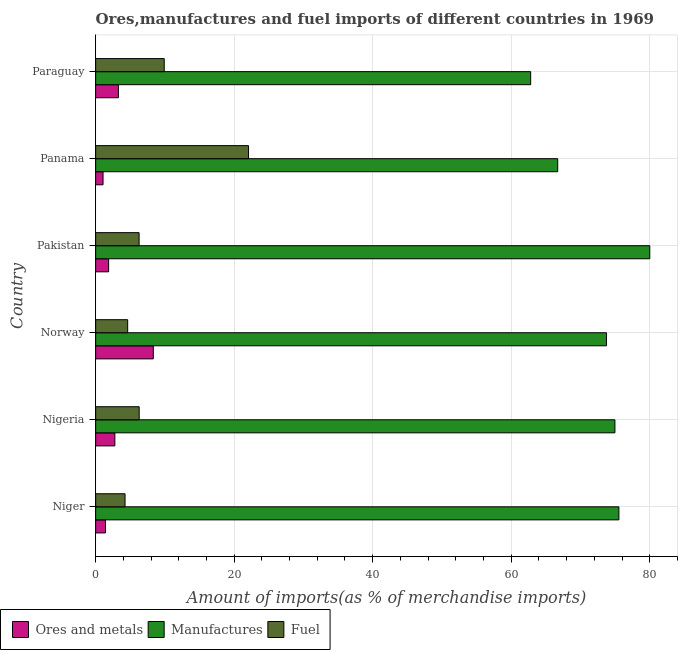How many different coloured bars are there?
Ensure brevity in your answer.  3. How many groups of bars are there?
Provide a short and direct response. 6. Are the number of bars per tick equal to the number of legend labels?
Your answer should be very brief. Yes. What is the label of the 6th group of bars from the top?
Offer a terse response. Niger. What is the percentage of fuel imports in Panama?
Your answer should be very brief. 22.07. Across all countries, what is the maximum percentage of ores and metals imports?
Give a very brief answer. 8.32. Across all countries, what is the minimum percentage of manufactures imports?
Give a very brief answer. 62.81. In which country was the percentage of fuel imports maximum?
Your answer should be compact. Panama. In which country was the percentage of fuel imports minimum?
Make the answer very short. Niger. What is the total percentage of fuel imports in the graph?
Offer a terse response. 53.4. What is the difference between the percentage of fuel imports in Pakistan and that in Paraguay?
Offer a very short reply. -3.63. What is the difference between the percentage of ores and metals imports in Panama and the percentage of manufactures imports in Niger?
Your answer should be very brief. -74.48. What is the average percentage of manufactures imports per country?
Your answer should be very brief. 72.3. What is the difference between the percentage of ores and metals imports and percentage of manufactures imports in Panama?
Give a very brief answer. -65.65. What is the ratio of the percentage of fuel imports in Norway to that in Panama?
Provide a succinct answer. 0.21. Is the difference between the percentage of ores and metals imports in Norway and Paraguay greater than the difference between the percentage of fuel imports in Norway and Paraguay?
Provide a short and direct response. Yes. What is the difference between the highest and the second highest percentage of manufactures imports?
Provide a succinct answer. 4.46. In how many countries, is the percentage of ores and metals imports greater than the average percentage of ores and metals imports taken over all countries?
Offer a very short reply. 2. Is the sum of the percentage of ores and metals imports in Nigeria and Pakistan greater than the maximum percentage of fuel imports across all countries?
Your answer should be compact. No. What does the 2nd bar from the top in Pakistan represents?
Give a very brief answer. Manufactures. What does the 3rd bar from the bottom in Pakistan represents?
Offer a terse response. Fuel. Is it the case that in every country, the sum of the percentage of ores and metals imports and percentage of manufactures imports is greater than the percentage of fuel imports?
Your answer should be very brief. Yes. How many bars are there?
Make the answer very short. 18. How many countries are there in the graph?
Ensure brevity in your answer.  6. What is the difference between two consecutive major ticks on the X-axis?
Offer a very short reply. 20. Are the values on the major ticks of X-axis written in scientific E-notation?
Keep it short and to the point. No. Does the graph contain grids?
Give a very brief answer. Yes. What is the title of the graph?
Your answer should be very brief. Ores,manufactures and fuel imports of different countries in 1969. What is the label or title of the X-axis?
Offer a terse response. Amount of imports(as % of merchandise imports). What is the label or title of the Y-axis?
Offer a terse response. Country. What is the Amount of imports(as % of merchandise imports) in Ores and metals in Niger?
Ensure brevity in your answer.  1.42. What is the Amount of imports(as % of merchandise imports) in Manufactures in Niger?
Offer a very short reply. 75.55. What is the Amount of imports(as % of merchandise imports) in Fuel in Niger?
Make the answer very short. 4.24. What is the Amount of imports(as % of merchandise imports) in Ores and metals in Nigeria?
Your answer should be very brief. 2.77. What is the Amount of imports(as % of merchandise imports) of Manufactures in Nigeria?
Keep it short and to the point. 74.97. What is the Amount of imports(as % of merchandise imports) in Fuel in Nigeria?
Ensure brevity in your answer.  6.28. What is the Amount of imports(as % of merchandise imports) in Ores and metals in Norway?
Give a very brief answer. 8.32. What is the Amount of imports(as % of merchandise imports) of Manufactures in Norway?
Ensure brevity in your answer.  73.75. What is the Amount of imports(as % of merchandise imports) in Fuel in Norway?
Offer a very short reply. 4.62. What is the Amount of imports(as % of merchandise imports) in Ores and metals in Pakistan?
Offer a terse response. 1.87. What is the Amount of imports(as % of merchandise imports) in Manufactures in Pakistan?
Ensure brevity in your answer.  80.01. What is the Amount of imports(as % of merchandise imports) of Fuel in Pakistan?
Give a very brief answer. 6.27. What is the Amount of imports(as % of merchandise imports) of Ores and metals in Panama?
Keep it short and to the point. 1.07. What is the Amount of imports(as % of merchandise imports) of Manufactures in Panama?
Keep it short and to the point. 66.71. What is the Amount of imports(as % of merchandise imports) in Fuel in Panama?
Keep it short and to the point. 22.07. What is the Amount of imports(as % of merchandise imports) of Ores and metals in Paraguay?
Provide a short and direct response. 3.28. What is the Amount of imports(as % of merchandise imports) of Manufactures in Paraguay?
Make the answer very short. 62.81. What is the Amount of imports(as % of merchandise imports) in Fuel in Paraguay?
Make the answer very short. 9.9. Across all countries, what is the maximum Amount of imports(as % of merchandise imports) in Ores and metals?
Give a very brief answer. 8.32. Across all countries, what is the maximum Amount of imports(as % of merchandise imports) in Manufactures?
Give a very brief answer. 80.01. Across all countries, what is the maximum Amount of imports(as % of merchandise imports) in Fuel?
Your answer should be compact. 22.07. Across all countries, what is the minimum Amount of imports(as % of merchandise imports) in Ores and metals?
Ensure brevity in your answer.  1.07. Across all countries, what is the minimum Amount of imports(as % of merchandise imports) in Manufactures?
Your answer should be very brief. 62.81. Across all countries, what is the minimum Amount of imports(as % of merchandise imports) of Fuel?
Offer a very short reply. 4.24. What is the total Amount of imports(as % of merchandise imports) of Ores and metals in the graph?
Keep it short and to the point. 18.74. What is the total Amount of imports(as % of merchandise imports) in Manufactures in the graph?
Provide a short and direct response. 433.81. What is the total Amount of imports(as % of merchandise imports) of Fuel in the graph?
Offer a very short reply. 53.4. What is the difference between the Amount of imports(as % of merchandise imports) in Ores and metals in Niger and that in Nigeria?
Give a very brief answer. -1.35. What is the difference between the Amount of imports(as % of merchandise imports) of Manufactures in Niger and that in Nigeria?
Offer a very short reply. 0.57. What is the difference between the Amount of imports(as % of merchandise imports) of Fuel in Niger and that in Nigeria?
Give a very brief answer. -2.04. What is the difference between the Amount of imports(as % of merchandise imports) of Ores and metals in Niger and that in Norway?
Ensure brevity in your answer.  -6.91. What is the difference between the Amount of imports(as % of merchandise imports) of Manufactures in Niger and that in Norway?
Keep it short and to the point. 1.79. What is the difference between the Amount of imports(as % of merchandise imports) of Fuel in Niger and that in Norway?
Ensure brevity in your answer.  -0.38. What is the difference between the Amount of imports(as % of merchandise imports) in Ores and metals in Niger and that in Pakistan?
Your answer should be very brief. -0.45. What is the difference between the Amount of imports(as % of merchandise imports) in Manufactures in Niger and that in Pakistan?
Your answer should be very brief. -4.46. What is the difference between the Amount of imports(as % of merchandise imports) of Fuel in Niger and that in Pakistan?
Offer a terse response. -2.03. What is the difference between the Amount of imports(as % of merchandise imports) of Ores and metals in Niger and that in Panama?
Keep it short and to the point. 0.35. What is the difference between the Amount of imports(as % of merchandise imports) of Manufactures in Niger and that in Panama?
Your response must be concise. 8.84. What is the difference between the Amount of imports(as % of merchandise imports) in Fuel in Niger and that in Panama?
Give a very brief answer. -17.83. What is the difference between the Amount of imports(as % of merchandise imports) of Ores and metals in Niger and that in Paraguay?
Your answer should be compact. -1.87. What is the difference between the Amount of imports(as % of merchandise imports) of Manufactures in Niger and that in Paraguay?
Provide a short and direct response. 12.74. What is the difference between the Amount of imports(as % of merchandise imports) in Fuel in Niger and that in Paraguay?
Make the answer very short. -5.66. What is the difference between the Amount of imports(as % of merchandise imports) of Ores and metals in Nigeria and that in Norway?
Offer a very short reply. -5.55. What is the difference between the Amount of imports(as % of merchandise imports) of Manufactures in Nigeria and that in Norway?
Keep it short and to the point. 1.22. What is the difference between the Amount of imports(as % of merchandise imports) in Fuel in Nigeria and that in Norway?
Provide a succinct answer. 1.66. What is the difference between the Amount of imports(as % of merchandise imports) in Ores and metals in Nigeria and that in Pakistan?
Give a very brief answer. 0.9. What is the difference between the Amount of imports(as % of merchandise imports) of Manufactures in Nigeria and that in Pakistan?
Offer a very short reply. -5.03. What is the difference between the Amount of imports(as % of merchandise imports) in Fuel in Nigeria and that in Pakistan?
Offer a terse response. 0.01. What is the difference between the Amount of imports(as % of merchandise imports) of Ores and metals in Nigeria and that in Panama?
Provide a succinct answer. 1.7. What is the difference between the Amount of imports(as % of merchandise imports) in Manufactures in Nigeria and that in Panama?
Provide a short and direct response. 8.26. What is the difference between the Amount of imports(as % of merchandise imports) in Fuel in Nigeria and that in Panama?
Keep it short and to the point. -15.79. What is the difference between the Amount of imports(as % of merchandise imports) of Ores and metals in Nigeria and that in Paraguay?
Keep it short and to the point. -0.51. What is the difference between the Amount of imports(as % of merchandise imports) in Manufactures in Nigeria and that in Paraguay?
Your answer should be compact. 12.16. What is the difference between the Amount of imports(as % of merchandise imports) of Fuel in Nigeria and that in Paraguay?
Keep it short and to the point. -3.61. What is the difference between the Amount of imports(as % of merchandise imports) in Ores and metals in Norway and that in Pakistan?
Offer a very short reply. 6.45. What is the difference between the Amount of imports(as % of merchandise imports) in Manufactures in Norway and that in Pakistan?
Ensure brevity in your answer.  -6.26. What is the difference between the Amount of imports(as % of merchandise imports) of Fuel in Norway and that in Pakistan?
Make the answer very short. -1.65. What is the difference between the Amount of imports(as % of merchandise imports) in Ores and metals in Norway and that in Panama?
Your response must be concise. 7.26. What is the difference between the Amount of imports(as % of merchandise imports) of Manufactures in Norway and that in Panama?
Your answer should be very brief. 7.04. What is the difference between the Amount of imports(as % of merchandise imports) in Fuel in Norway and that in Panama?
Offer a very short reply. -17.45. What is the difference between the Amount of imports(as % of merchandise imports) of Ores and metals in Norway and that in Paraguay?
Your response must be concise. 5.04. What is the difference between the Amount of imports(as % of merchandise imports) in Manufactures in Norway and that in Paraguay?
Make the answer very short. 10.94. What is the difference between the Amount of imports(as % of merchandise imports) of Fuel in Norway and that in Paraguay?
Your response must be concise. -5.28. What is the difference between the Amount of imports(as % of merchandise imports) in Ores and metals in Pakistan and that in Panama?
Your answer should be compact. 0.81. What is the difference between the Amount of imports(as % of merchandise imports) of Manufactures in Pakistan and that in Panama?
Provide a succinct answer. 13.3. What is the difference between the Amount of imports(as % of merchandise imports) in Fuel in Pakistan and that in Panama?
Provide a short and direct response. -15.8. What is the difference between the Amount of imports(as % of merchandise imports) in Ores and metals in Pakistan and that in Paraguay?
Provide a short and direct response. -1.41. What is the difference between the Amount of imports(as % of merchandise imports) in Manufactures in Pakistan and that in Paraguay?
Offer a very short reply. 17.2. What is the difference between the Amount of imports(as % of merchandise imports) in Fuel in Pakistan and that in Paraguay?
Your response must be concise. -3.63. What is the difference between the Amount of imports(as % of merchandise imports) of Ores and metals in Panama and that in Paraguay?
Make the answer very short. -2.22. What is the difference between the Amount of imports(as % of merchandise imports) in Manufactures in Panama and that in Paraguay?
Your answer should be very brief. 3.9. What is the difference between the Amount of imports(as % of merchandise imports) of Fuel in Panama and that in Paraguay?
Offer a terse response. 12.17. What is the difference between the Amount of imports(as % of merchandise imports) in Ores and metals in Niger and the Amount of imports(as % of merchandise imports) in Manufactures in Nigeria?
Give a very brief answer. -73.56. What is the difference between the Amount of imports(as % of merchandise imports) of Ores and metals in Niger and the Amount of imports(as % of merchandise imports) of Fuel in Nigeria?
Give a very brief answer. -4.87. What is the difference between the Amount of imports(as % of merchandise imports) of Manufactures in Niger and the Amount of imports(as % of merchandise imports) of Fuel in Nigeria?
Provide a short and direct response. 69.26. What is the difference between the Amount of imports(as % of merchandise imports) in Ores and metals in Niger and the Amount of imports(as % of merchandise imports) in Manufactures in Norway?
Provide a succinct answer. -72.33. What is the difference between the Amount of imports(as % of merchandise imports) in Ores and metals in Niger and the Amount of imports(as % of merchandise imports) in Fuel in Norway?
Your response must be concise. -3.2. What is the difference between the Amount of imports(as % of merchandise imports) in Manufactures in Niger and the Amount of imports(as % of merchandise imports) in Fuel in Norway?
Provide a succinct answer. 70.93. What is the difference between the Amount of imports(as % of merchandise imports) in Ores and metals in Niger and the Amount of imports(as % of merchandise imports) in Manufactures in Pakistan?
Keep it short and to the point. -78.59. What is the difference between the Amount of imports(as % of merchandise imports) of Ores and metals in Niger and the Amount of imports(as % of merchandise imports) of Fuel in Pakistan?
Offer a terse response. -4.85. What is the difference between the Amount of imports(as % of merchandise imports) in Manufactures in Niger and the Amount of imports(as % of merchandise imports) in Fuel in Pakistan?
Make the answer very short. 69.28. What is the difference between the Amount of imports(as % of merchandise imports) of Ores and metals in Niger and the Amount of imports(as % of merchandise imports) of Manufactures in Panama?
Ensure brevity in your answer.  -65.29. What is the difference between the Amount of imports(as % of merchandise imports) of Ores and metals in Niger and the Amount of imports(as % of merchandise imports) of Fuel in Panama?
Your answer should be very brief. -20.65. What is the difference between the Amount of imports(as % of merchandise imports) in Manufactures in Niger and the Amount of imports(as % of merchandise imports) in Fuel in Panama?
Offer a very short reply. 53.48. What is the difference between the Amount of imports(as % of merchandise imports) of Ores and metals in Niger and the Amount of imports(as % of merchandise imports) of Manufactures in Paraguay?
Keep it short and to the point. -61.39. What is the difference between the Amount of imports(as % of merchandise imports) of Ores and metals in Niger and the Amount of imports(as % of merchandise imports) of Fuel in Paraguay?
Your response must be concise. -8.48. What is the difference between the Amount of imports(as % of merchandise imports) in Manufactures in Niger and the Amount of imports(as % of merchandise imports) in Fuel in Paraguay?
Provide a short and direct response. 65.65. What is the difference between the Amount of imports(as % of merchandise imports) in Ores and metals in Nigeria and the Amount of imports(as % of merchandise imports) in Manufactures in Norway?
Offer a terse response. -70.98. What is the difference between the Amount of imports(as % of merchandise imports) of Ores and metals in Nigeria and the Amount of imports(as % of merchandise imports) of Fuel in Norway?
Your response must be concise. -1.85. What is the difference between the Amount of imports(as % of merchandise imports) of Manufactures in Nigeria and the Amount of imports(as % of merchandise imports) of Fuel in Norway?
Make the answer very short. 70.35. What is the difference between the Amount of imports(as % of merchandise imports) in Ores and metals in Nigeria and the Amount of imports(as % of merchandise imports) in Manufactures in Pakistan?
Make the answer very short. -77.24. What is the difference between the Amount of imports(as % of merchandise imports) of Ores and metals in Nigeria and the Amount of imports(as % of merchandise imports) of Fuel in Pakistan?
Offer a very short reply. -3.5. What is the difference between the Amount of imports(as % of merchandise imports) of Manufactures in Nigeria and the Amount of imports(as % of merchandise imports) of Fuel in Pakistan?
Your answer should be very brief. 68.7. What is the difference between the Amount of imports(as % of merchandise imports) in Ores and metals in Nigeria and the Amount of imports(as % of merchandise imports) in Manufactures in Panama?
Ensure brevity in your answer.  -63.94. What is the difference between the Amount of imports(as % of merchandise imports) of Ores and metals in Nigeria and the Amount of imports(as % of merchandise imports) of Fuel in Panama?
Make the answer very short. -19.3. What is the difference between the Amount of imports(as % of merchandise imports) of Manufactures in Nigeria and the Amount of imports(as % of merchandise imports) of Fuel in Panama?
Your response must be concise. 52.9. What is the difference between the Amount of imports(as % of merchandise imports) in Ores and metals in Nigeria and the Amount of imports(as % of merchandise imports) in Manufactures in Paraguay?
Make the answer very short. -60.04. What is the difference between the Amount of imports(as % of merchandise imports) in Ores and metals in Nigeria and the Amount of imports(as % of merchandise imports) in Fuel in Paraguay?
Give a very brief answer. -7.13. What is the difference between the Amount of imports(as % of merchandise imports) in Manufactures in Nigeria and the Amount of imports(as % of merchandise imports) in Fuel in Paraguay?
Provide a short and direct response. 65.07. What is the difference between the Amount of imports(as % of merchandise imports) in Ores and metals in Norway and the Amount of imports(as % of merchandise imports) in Manufactures in Pakistan?
Give a very brief answer. -71.68. What is the difference between the Amount of imports(as % of merchandise imports) in Ores and metals in Norway and the Amount of imports(as % of merchandise imports) in Fuel in Pakistan?
Offer a terse response. 2.05. What is the difference between the Amount of imports(as % of merchandise imports) of Manufactures in Norway and the Amount of imports(as % of merchandise imports) of Fuel in Pakistan?
Give a very brief answer. 67.48. What is the difference between the Amount of imports(as % of merchandise imports) of Ores and metals in Norway and the Amount of imports(as % of merchandise imports) of Manufactures in Panama?
Offer a very short reply. -58.39. What is the difference between the Amount of imports(as % of merchandise imports) of Ores and metals in Norway and the Amount of imports(as % of merchandise imports) of Fuel in Panama?
Offer a very short reply. -13.75. What is the difference between the Amount of imports(as % of merchandise imports) of Manufactures in Norway and the Amount of imports(as % of merchandise imports) of Fuel in Panama?
Give a very brief answer. 51.68. What is the difference between the Amount of imports(as % of merchandise imports) in Ores and metals in Norway and the Amount of imports(as % of merchandise imports) in Manufactures in Paraguay?
Offer a terse response. -54.49. What is the difference between the Amount of imports(as % of merchandise imports) in Ores and metals in Norway and the Amount of imports(as % of merchandise imports) in Fuel in Paraguay?
Make the answer very short. -1.58. What is the difference between the Amount of imports(as % of merchandise imports) in Manufactures in Norway and the Amount of imports(as % of merchandise imports) in Fuel in Paraguay?
Make the answer very short. 63.85. What is the difference between the Amount of imports(as % of merchandise imports) in Ores and metals in Pakistan and the Amount of imports(as % of merchandise imports) in Manufactures in Panama?
Provide a succinct answer. -64.84. What is the difference between the Amount of imports(as % of merchandise imports) of Ores and metals in Pakistan and the Amount of imports(as % of merchandise imports) of Fuel in Panama?
Offer a very short reply. -20.2. What is the difference between the Amount of imports(as % of merchandise imports) of Manufactures in Pakistan and the Amount of imports(as % of merchandise imports) of Fuel in Panama?
Keep it short and to the point. 57.94. What is the difference between the Amount of imports(as % of merchandise imports) of Ores and metals in Pakistan and the Amount of imports(as % of merchandise imports) of Manufactures in Paraguay?
Keep it short and to the point. -60.94. What is the difference between the Amount of imports(as % of merchandise imports) in Ores and metals in Pakistan and the Amount of imports(as % of merchandise imports) in Fuel in Paraguay?
Offer a terse response. -8.03. What is the difference between the Amount of imports(as % of merchandise imports) of Manufactures in Pakistan and the Amount of imports(as % of merchandise imports) of Fuel in Paraguay?
Offer a terse response. 70.11. What is the difference between the Amount of imports(as % of merchandise imports) of Ores and metals in Panama and the Amount of imports(as % of merchandise imports) of Manufactures in Paraguay?
Ensure brevity in your answer.  -61.74. What is the difference between the Amount of imports(as % of merchandise imports) in Ores and metals in Panama and the Amount of imports(as % of merchandise imports) in Fuel in Paraguay?
Offer a terse response. -8.83. What is the difference between the Amount of imports(as % of merchandise imports) in Manufactures in Panama and the Amount of imports(as % of merchandise imports) in Fuel in Paraguay?
Offer a terse response. 56.81. What is the average Amount of imports(as % of merchandise imports) in Ores and metals per country?
Offer a terse response. 3.12. What is the average Amount of imports(as % of merchandise imports) in Manufactures per country?
Your answer should be very brief. 72.3. What is the average Amount of imports(as % of merchandise imports) in Fuel per country?
Your answer should be compact. 8.9. What is the difference between the Amount of imports(as % of merchandise imports) in Ores and metals and Amount of imports(as % of merchandise imports) in Manufactures in Niger?
Provide a short and direct response. -74.13. What is the difference between the Amount of imports(as % of merchandise imports) in Ores and metals and Amount of imports(as % of merchandise imports) in Fuel in Niger?
Provide a short and direct response. -2.82. What is the difference between the Amount of imports(as % of merchandise imports) in Manufactures and Amount of imports(as % of merchandise imports) in Fuel in Niger?
Give a very brief answer. 71.31. What is the difference between the Amount of imports(as % of merchandise imports) of Ores and metals and Amount of imports(as % of merchandise imports) of Manufactures in Nigeria?
Provide a short and direct response. -72.2. What is the difference between the Amount of imports(as % of merchandise imports) of Ores and metals and Amount of imports(as % of merchandise imports) of Fuel in Nigeria?
Keep it short and to the point. -3.51. What is the difference between the Amount of imports(as % of merchandise imports) in Manufactures and Amount of imports(as % of merchandise imports) in Fuel in Nigeria?
Give a very brief answer. 68.69. What is the difference between the Amount of imports(as % of merchandise imports) in Ores and metals and Amount of imports(as % of merchandise imports) in Manufactures in Norway?
Give a very brief answer. -65.43. What is the difference between the Amount of imports(as % of merchandise imports) of Ores and metals and Amount of imports(as % of merchandise imports) of Fuel in Norway?
Make the answer very short. 3.7. What is the difference between the Amount of imports(as % of merchandise imports) in Manufactures and Amount of imports(as % of merchandise imports) in Fuel in Norway?
Your answer should be compact. 69.13. What is the difference between the Amount of imports(as % of merchandise imports) in Ores and metals and Amount of imports(as % of merchandise imports) in Manufactures in Pakistan?
Provide a succinct answer. -78.14. What is the difference between the Amount of imports(as % of merchandise imports) of Ores and metals and Amount of imports(as % of merchandise imports) of Fuel in Pakistan?
Your answer should be very brief. -4.4. What is the difference between the Amount of imports(as % of merchandise imports) in Manufactures and Amount of imports(as % of merchandise imports) in Fuel in Pakistan?
Ensure brevity in your answer.  73.74. What is the difference between the Amount of imports(as % of merchandise imports) of Ores and metals and Amount of imports(as % of merchandise imports) of Manufactures in Panama?
Offer a terse response. -65.65. What is the difference between the Amount of imports(as % of merchandise imports) in Ores and metals and Amount of imports(as % of merchandise imports) in Fuel in Panama?
Provide a succinct answer. -21.01. What is the difference between the Amount of imports(as % of merchandise imports) in Manufactures and Amount of imports(as % of merchandise imports) in Fuel in Panama?
Offer a very short reply. 44.64. What is the difference between the Amount of imports(as % of merchandise imports) in Ores and metals and Amount of imports(as % of merchandise imports) in Manufactures in Paraguay?
Keep it short and to the point. -59.53. What is the difference between the Amount of imports(as % of merchandise imports) in Ores and metals and Amount of imports(as % of merchandise imports) in Fuel in Paraguay?
Ensure brevity in your answer.  -6.62. What is the difference between the Amount of imports(as % of merchandise imports) of Manufactures and Amount of imports(as % of merchandise imports) of Fuel in Paraguay?
Ensure brevity in your answer.  52.91. What is the ratio of the Amount of imports(as % of merchandise imports) in Ores and metals in Niger to that in Nigeria?
Your answer should be compact. 0.51. What is the ratio of the Amount of imports(as % of merchandise imports) in Manufactures in Niger to that in Nigeria?
Ensure brevity in your answer.  1.01. What is the ratio of the Amount of imports(as % of merchandise imports) of Fuel in Niger to that in Nigeria?
Offer a terse response. 0.68. What is the ratio of the Amount of imports(as % of merchandise imports) of Ores and metals in Niger to that in Norway?
Offer a terse response. 0.17. What is the ratio of the Amount of imports(as % of merchandise imports) in Manufactures in Niger to that in Norway?
Your answer should be very brief. 1.02. What is the ratio of the Amount of imports(as % of merchandise imports) of Fuel in Niger to that in Norway?
Give a very brief answer. 0.92. What is the ratio of the Amount of imports(as % of merchandise imports) in Ores and metals in Niger to that in Pakistan?
Your response must be concise. 0.76. What is the ratio of the Amount of imports(as % of merchandise imports) in Manufactures in Niger to that in Pakistan?
Your answer should be compact. 0.94. What is the ratio of the Amount of imports(as % of merchandise imports) in Fuel in Niger to that in Pakistan?
Keep it short and to the point. 0.68. What is the ratio of the Amount of imports(as % of merchandise imports) of Ores and metals in Niger to that in Panama?
Provide a short and direct response. 1.33. What is the ratio of the Amount of imports(as % of merchandise imports) of Manufactures in Niger to that in Panama?
Your answer should be compact. 1.13. What is the ratio of the Amount of imports(as % of merchandise imports) in Fuel in Niger to that in Panama?
Offer a very short reply. 0.19. What is the ratio of the Amount of imports(as % of merchandise imports) of Ores and metals in Niger to that in Paraguay?
Ensure brevity in your answer.  0.43. What is the ratio of the Amount of imports(as % of merchandise imports) in Manufactures in Niger to that in Paraguay?
Provide a short and direct response. 1.2. What is the ratio of the Amount of imports(as % of merchandise imports) of Fuel in Niger to that in Paraguay?
Your answer should be very brief. 0.43. What is the ratio of the Amount of imports(as % of merchandise imports) of Ores and metals in Nigeria to that in Norway?
Give a very brief answer. 0.33. What is the ratio of the Amount of imports(as % of merchandise imports) of Manufactures in Nigeria to that in Norway?
Offer a terse response. 1.02. What is the ratio of the Amount of imports(as % of merchandise imports) in Fuel in Nigeria to that in Norway?
Your answer should be compact. 1.36. What is the ratio of the Amount of imports(as % of merchandise imports) of Ores and metals in Nigeria to that in Pakistan?
Your response must be concise. 1.48. What is the ratio of the Amount of imports(as % of merchandise imports) of Manufactures in Nigeria to that in Pakistan?
Provide a succinct answer. 0.94. What is the ratio of the Amount of imports(as % of merchandise imports) of Ores and metals in Nigeria to that in Panama?
Keep it short and to the point. 2.6. What is the ratio of the Amount of imports(as % of merchandise imports) in Manufactures in Nigeria to that in Panama?
Provide a short and direct response. 1.12. What is the ratio of the Amount of imports(as % of merchandise imports) in Fuel in Nigeria to that in Panama?
Provide a succinct answer. 0.28. What is the ratio of the Amount of imports(as % of merchandise imports) in Ores and metals in Nigeria to that in Paraguay?
Make the answer very short. 0.84. What is the ratio of the Amount of imports(as % of merchandise imports) in Manufactures in Nigeria to that in Paraguay?
Your answer should be compact. 1.19. What is the ratio of the Amount of imports(as % of merchandise imports) of Fuel in Nigeria to that in Paraguay?
Offer a terse response. 0.63. What is the ratio of the Amount of imports(as % of merchandise imports) of Ores and metals in Norway to that in Pakistan?
Offer a very short reply. 4.45. What is the ratio of the Amount of imports(as % of merchandise imports) of Manufactures in Norway to that in Pakistan?
Offer a terse response. 0.92. What is the ratio of the Amount of imports(as % of merchandise imports) in Fuel in Norway to that in Pakistan?
Ensure brevity in your answer.  0.74. What is the ratio of the Amount of imports(as % of merchandise imports) in Ores and metals in Norway to that in Panama?
Keep it short and to the point. 7.8. What is the ratio of the Amount of imports(as % of merchandise imports) of Manufactures in Norway to that in Panama?
Your answer should be compact. 1.11. What is the ratio of the Amount of imports(as % of merchandise imports) in Fuel in Norway to that in Panama?
Your response must be concise. 0.21. What is the ratio of the Amount of imports(as % of merchandise imports) in Ores and metals in Norway to that in Paraguay?
Your answer should be very brief. 2.53. What is the ratio of the Amount of imports(as % of merchandise imports) of Manufactures in Norway to that in Paraguay?
Provide a short and direct response. 1.17. What is the ratio of the Amount of imports(as % of merchandise imports) of Fuel in Norway to that in Paraguay?
Ensure brevity in your answer.  0.47. What is the ratio of the Amount of imports(as % of merchandise imports) in Ores and metals in Pakistan to that in Panama?
Ensure brevity in your answer.  1.75. What is the ratio of the Amount of imports(as % of merchandise imports) of Manufactures in Pakistan to that in Panama?
Provide a short and direct response. 1.2. What is the ratio of the Amount of imports(as % of merchandise imports) of Fuel in Pakistan to that in Panama?
Give a very brief answer. 0.28. What is the ratio of the Amount of imports(as % of merchandise imports) in Ores and metals in Pakistan to that in Paraguay?
Offer a very short reply. 0.57. What is the ratio of the Amount of imports(as % of merchandise imports) in Manufactures in Pakistan to that in Paraguay?
Offer a very short reply. 1.27. What is the ratio of the Amount of imports(as % of merchandise imports) in Fuel in Pakistan to that in Paraguay?
Keep it short and to the point. 0.63. What is the ratio of the Amount of imports(as % of merchandise imports) in Ores and metals in Panama to that in Paraguay?
Keep it short and to the point. 0.32. What is the ratio of the Amount of imports(as % of merchandise imports) of Manufactures in Panama to that in Paraguay?
Your response must be concise. 1.06. What is the ratio of the Amount of imports(as % of merchandise imports) of Fuel in Panama to that in Paraguay?
Offer a very short reply. 2.23. What is the difference between the highest and the second highest Amount of imports(as % of merchandise imports) of Ores and metals?
Offer a very short reply. 5.04. What is the difference between the highest and the second highest Amount of imports(as % of merchandise imports) of Manufactures?
Your answer should be compact. 4.46. What is the difference between the highest and the second highest Amount of imports(as % of merchandise imports) in Fuel?
Keep it short and to the point. 12.17. What is the difference between the highest and the lowest Amount of imports(as % of merchandise imports) in Ores and metals?
Your answer should be very brief. 7.26. What is the difference between the highest and the lowest Amount of imports(as % of merchandise imports) in Manufactures?
Offer a very short reply. 17.2. What is the difference between the highest and the lowest Amount of imports(as % of merchandise imports) in Fuel?
Provide a succinct answer. 17.83. 